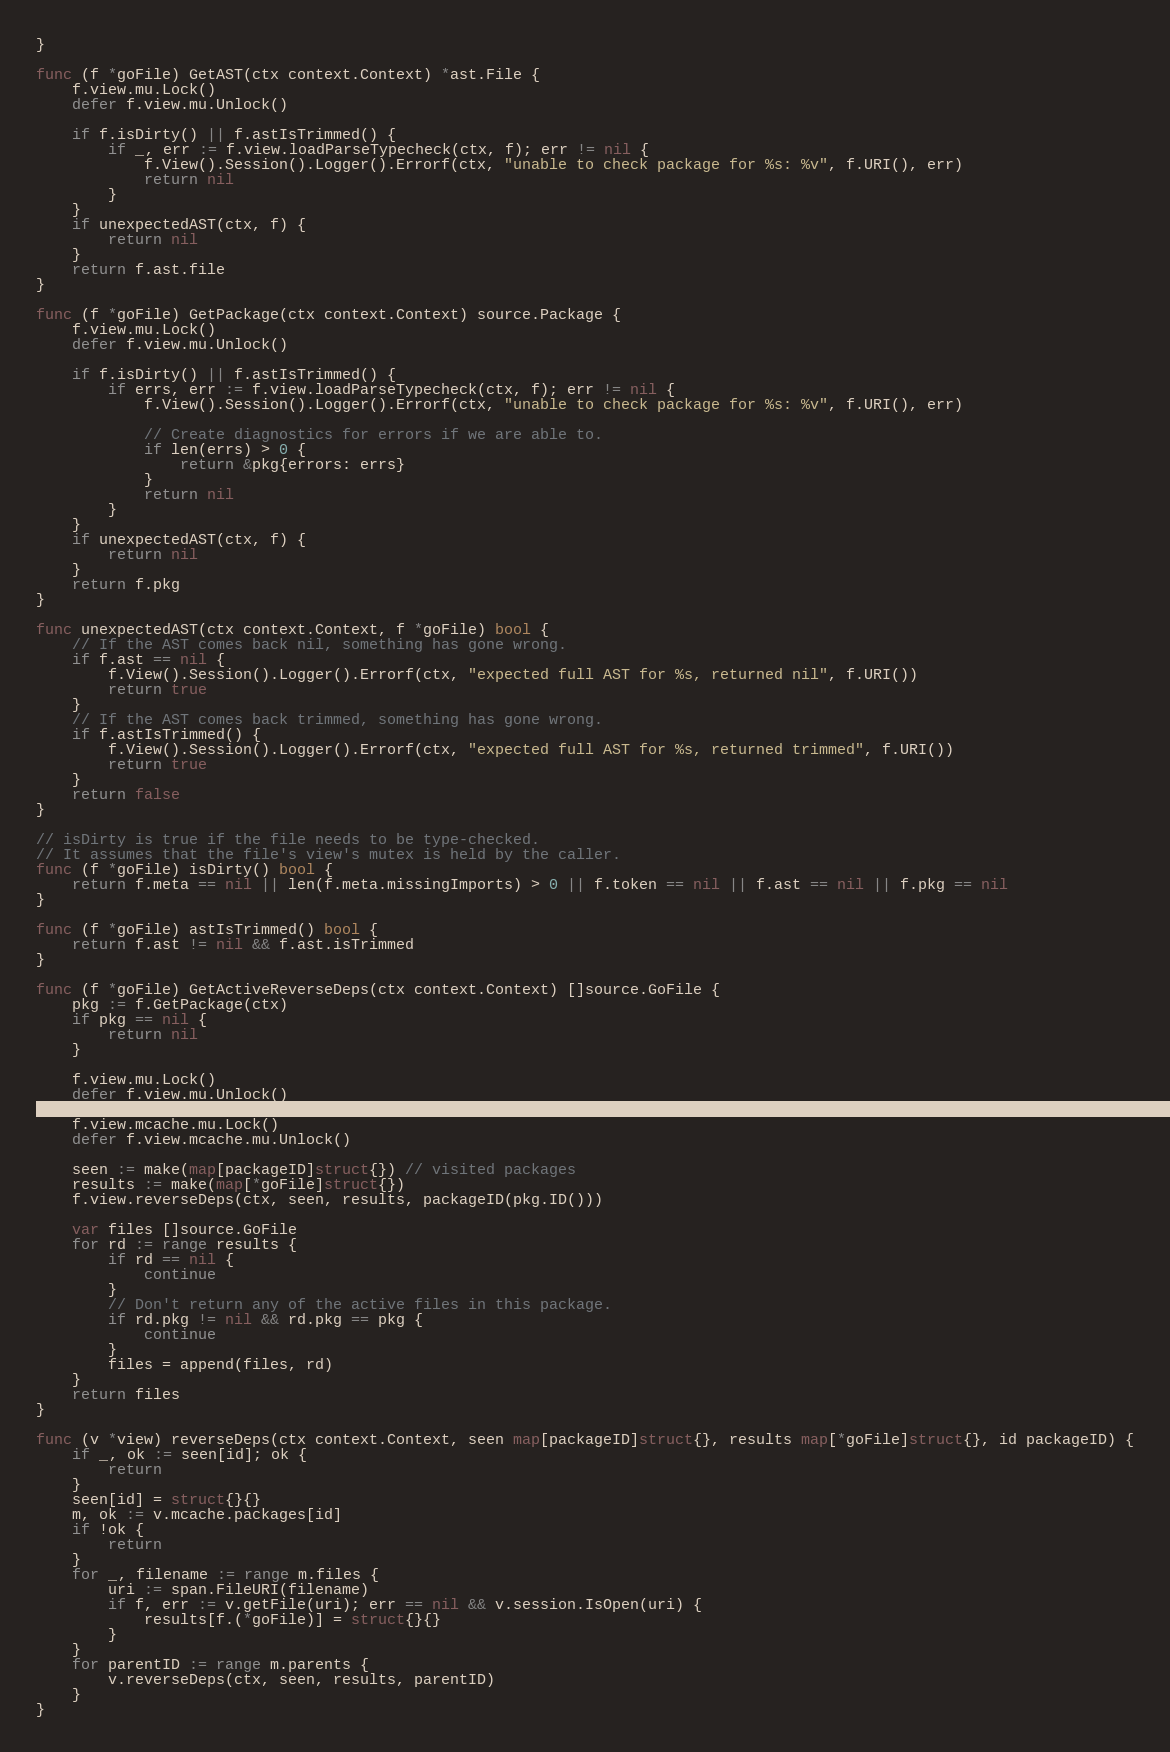Convert code to text. <code><loc_0><loc_0><loc_500><loc_500><_Go_>}

func (f *goFile) GetAST(ctx context.Context) *ast.File {
	f.view.mu.Lock()
	defer f.view.mu.Unlock()

	if f.isDirty() || f.astIsTrimmed() {
		if _, err := f.view.loadParseTypecheck(ctx, f); err != nil {
			f.View().Session().Logger().Errorf(ctx, "unable to check package for %s: %v", f.URI(), err)
			return nil
		}
	}
	if unexpectedAST(ctx, f) {
		return nil
	}
	return f.ast.file
}

func (f *goFile) GetPackage(ctx context.Context) source.Package {
	f.view.mu.Lock()
	defer f.view.mu.Unlock()

	if f.isDirty() || f.astIsTrimmed() {
		if errs, err := f.view.loadParseTypecheck(ctx, f); err != nil {
			f.View().Session().Logger().Errorf(ctx, "unable to check package for %s: %v", f.URI(), err)

			// Create diagnostics for errors if we are able to.
			if len(errs) > 0 {
				return &pkg{errors: errs}
			}
			return nil
		}
	}
	if unexpectedAST(ctx, f) {
		return nil
	}
	return f.pkg
}

func unexpectedAST(ctx context.Context, f *goFile) bool {
	// If the AST comes back nil, something has gone wrong.
	if f.ast == nil {
		f.View().Session().Logger().Errorf(ctx, "expected full AST for %s, returned nil", f.URI())
		return true
	}
	// If the AST comes back trimmed, something has gone wrong.
	if f.astIsTrimmed() {
		f.View().Session().Logger().Errorf(ctx, "expected full AST for %s, returned trimmed", f.URI())
		return true
	}
	return false
}

// isDirty is true if the file needs to be type-checked.
// It assumes that the file's view's mutex is held by the caller.
func (f *goFile) isDirty() bool {
	return f.meta == nil || len(f.meta.missingImports) > 0 || f.token == nil || f.ast == nil || f.pkg == nil
}

func (f *goFile) astIsTrimmed() bool {
	return f.ast != nil && f.ast.isTrimmed
}

func (f *goFile) GetActiveReverseDeps(ctx context.Context) []source.GoFile {
	pkg := f.GetPackage(ctx)
	if pkg == nil {
		return nil
	}

	f.view.mu.Lock()
	defer f.view.mu.Unlock()

	f.view.mcache.mu.Lock()
	defer f.view.mcache.mu.Unlock()

	seen := make(map[packageID]struct{}) // visited packages
	results := make(map[*goFile]struct{})
	f.view.reverseDeps(ctx, seen, results, packageID(pkg.ID()))

	var files []source.GoFile
	for rd := range results {
		if rd == nil {
			continue
		}
		// Don't return any of the active files in this package.
		if rd.pkg != nil && rd.pkg == pkg {
			continue
		}
		files = append(files, rd)
	}
	return files
}

func (v *view) reverseDeps(ctx context.Context, seen map[packageID]struct{}, results map[*goFile]struct{}, id packageID) {
	if _, ok := seen[id]; ok {
		return
	}
	seen[id] = struct{}{}
	m, ok := v.mcache.packages[id]
	if !ok {
		return
	}
	for _, filename := range m.files {
		uri := span.FileURI(filename)
		if f, err := v.getFile(uri); err == nil && v.session.IsOpen(uri) {
			results[f.(*goFile)] = struct{}{}
		}
	}
	for parentID := range m.parents {
		v.reverseDeps(ctx, seen, results, parentID)
	}
}
</code> 